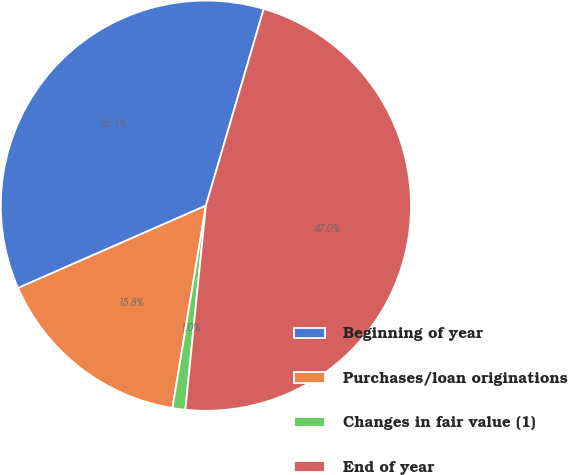Convert chart. <chart><loc_0><loc_0><loc_500><loc_500><pie_chart><fcel>Beginning of year<fcel>Purchases/loan originations<fcel>Changes in fair value (1)<fcel>End of year<nl><fcel>36.13%<fcel>15.82%<fcel>1.01%<fcel>47.05%<nl></chart> 